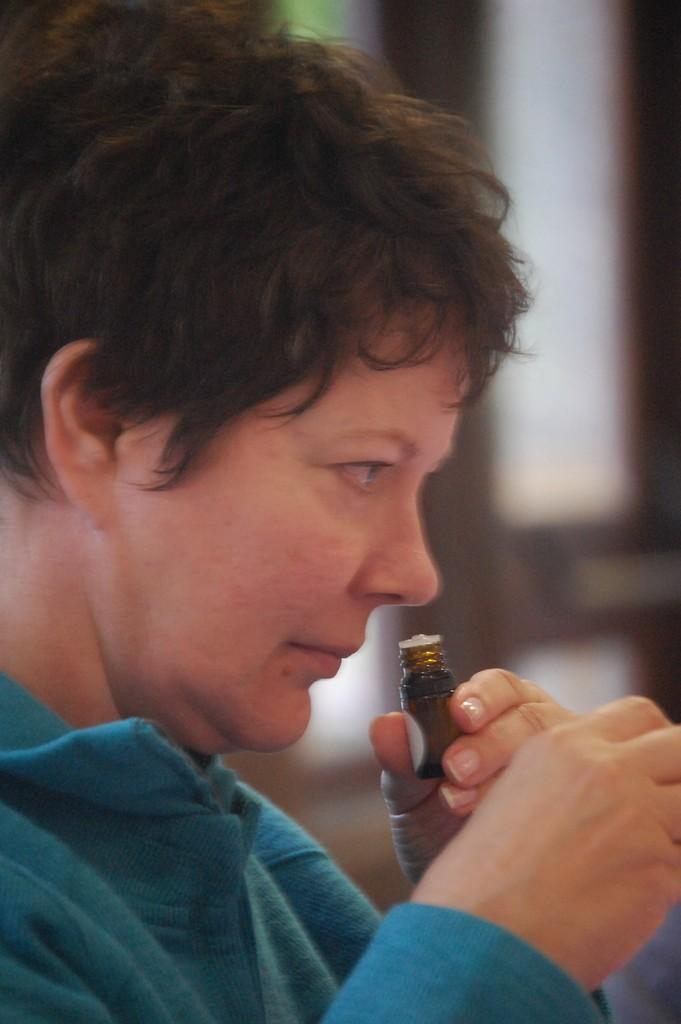What is the main subject of the image? There is a person in the image. What is the person holding in the image? The person is holding a small bottle. What is the person doing with the bottle? The person is smelling the bottle. Can you describe the background of the image? The background of the image is blurred. What type of joke is the worm telling the cattle in the image? There is no joke, worm, or cattle present in the image; it only features a person holding and smelling a small bottle. 